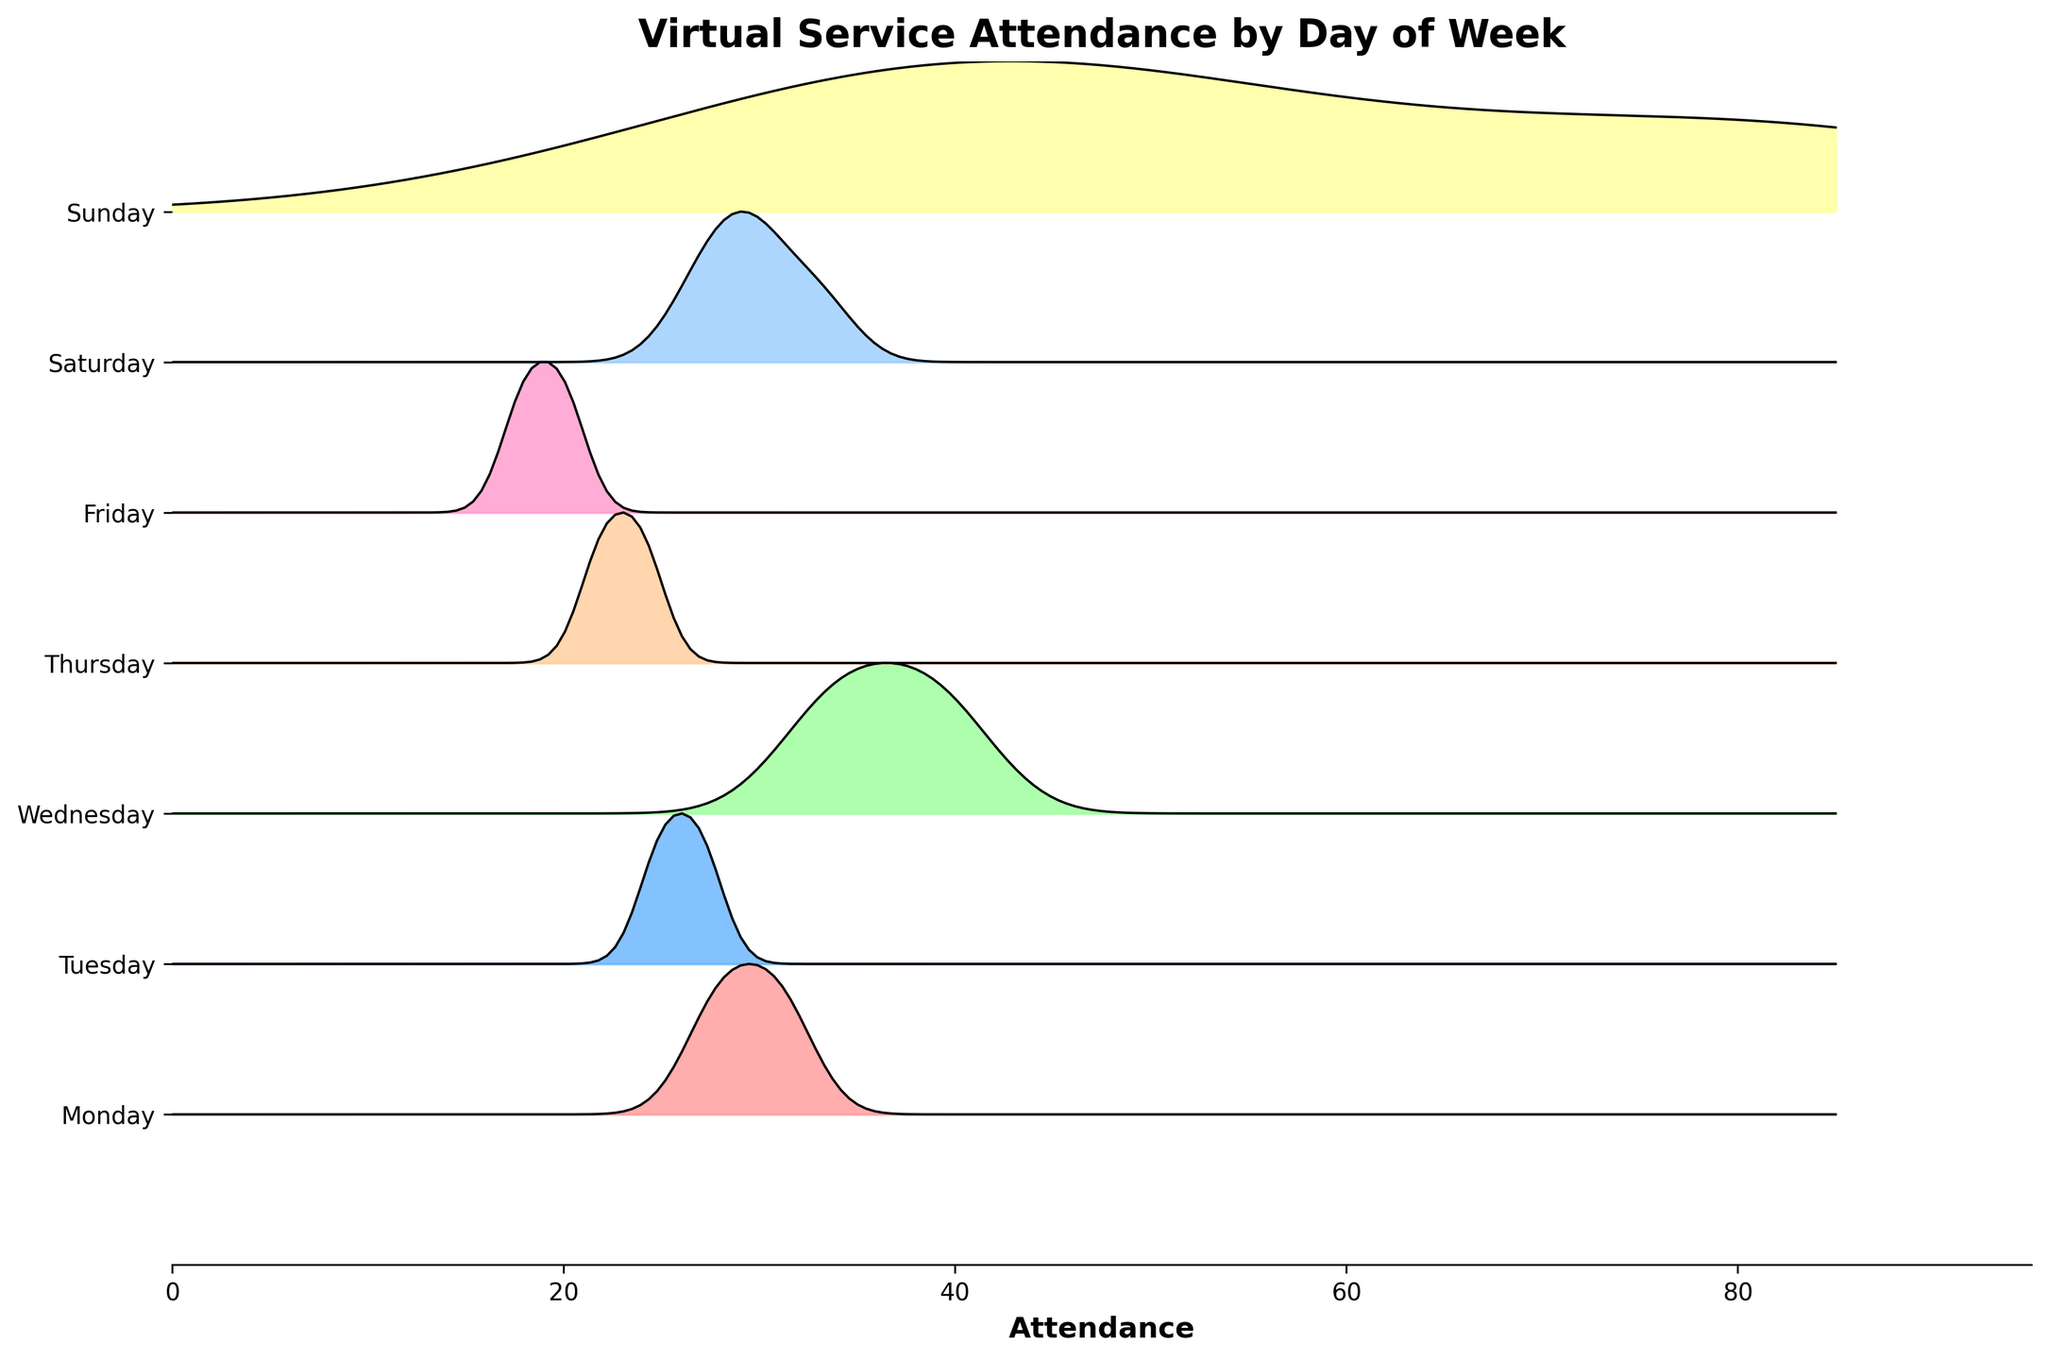What's the title of the figure? The title of the figure is usually found at the top and provides a summary of the entire plot. Here, it states "Virtual Service Attendance by Day of Week".
Answer: Virtual Service Attendance by Day of Week What color represents Sunday in the plot? In the plot, different colors represent different days of the week. The color for Sunday is typically a distinct shade. Based on the custom colormap, Sunday is represented by a yellow color.
Answer: Yellow Which day of the week shows the highest peak in attendance? To find the highest peak, look for the day with the tallest and most pronounced peak in the plot. Based on the ridgeline plot, Sunday has the highest peak in attendance.
Answer: Sunday How does the attendance trend on Wednesday compare to that on Thursday? We compare the peaks and distribution of attendance on Wednesday and Thursday. Wednesday has a higher peak and broader distribution compared to Thursday, indicating generally higher attendance on Wednesday.
Answer: Wednesday has higher attendance than Thursday What is the pattern of attendance on Saturdays? To identify the pattern, observe the ridgeline for Saturday. Saturdays have two ridges corresponding to times at 18:00 and 20:00 with moderate peaks, indicating some variation in attendance but not as high as Sunday.
Answer: Moderate peaks at 18:00 and 20:00 Which day has the lowest peak in attendance? To find the lowest peak, look for the day with the smallest and least pronounced peak. The ridgeline plot shows that Friday has the lowest peak in attendance.
Answer: Friday On which day does the attendance distribution appear the broadest? The broadest attendance distribution will show a wider spread from the base to the peak. Wednesday's distribution appears broader compared to other days, indicating a more varied attendance.
Answer: Wednesday Is there any day that has multiple attendance peaks? Check the ridgelines for any days with more than one peak. Saturday has multiple peaks in the attendance ridgeline, indicating two different service times.
Answer: Saturday 